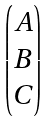Convert formula to latex. <formula><loc_0><loc_0><loc_500><loc_500>\begin{pmatrix} A \\ B \\ C \end{pmatrix}</formula> 